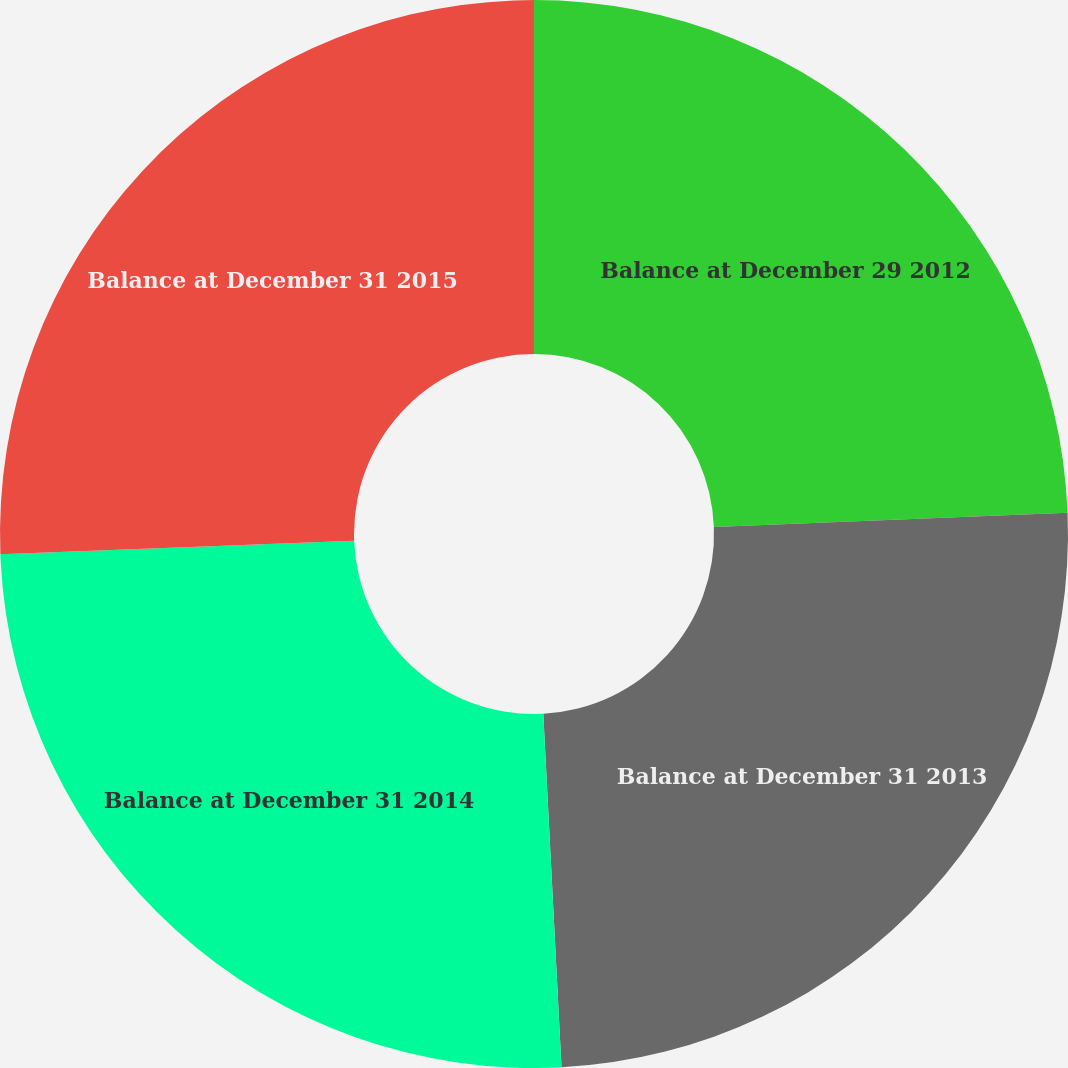Convert chart to OTSL. <chart><loc_0><loc_0><loc_500><loc_500><pie_chart><fcel>Balance at December 29 2012<fcel>Balance at December 31 2013<fcel>Balance at December 31 2014<fcel>Balance at December 31 2015<nl><fcel>24.37%<fcel>24.81%<fcel>25.22%<fcel>25.6%<nl></chart> 